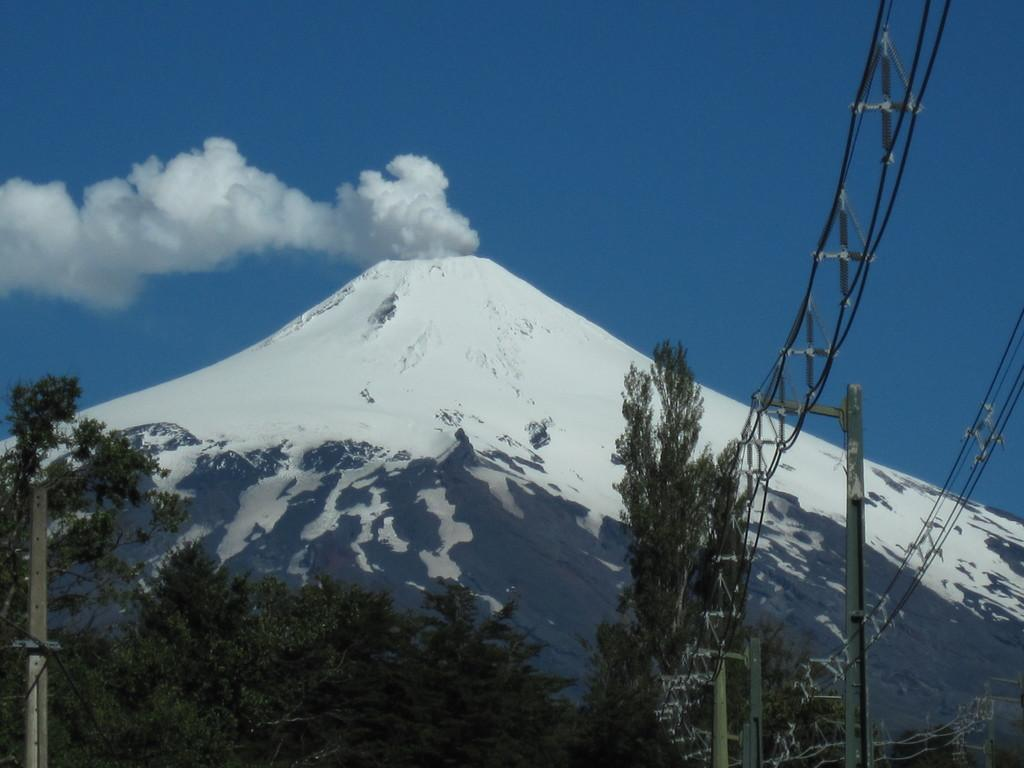What is the primary feature of the landscape in the image? There are many trees in the image. What can be seen to the right of the image? There are wires visible to the right of the image. What type of geographical feature is visible in the background? There are mountains visible in the background. What is the color of the sky in the background? The sky is blue in the background. What else can be observed in the background of the image? There is smoke visible in the background. Can you hear the thunder in the image? There is no thunder present in the image, as it is a visual medium and does not convey sound. 